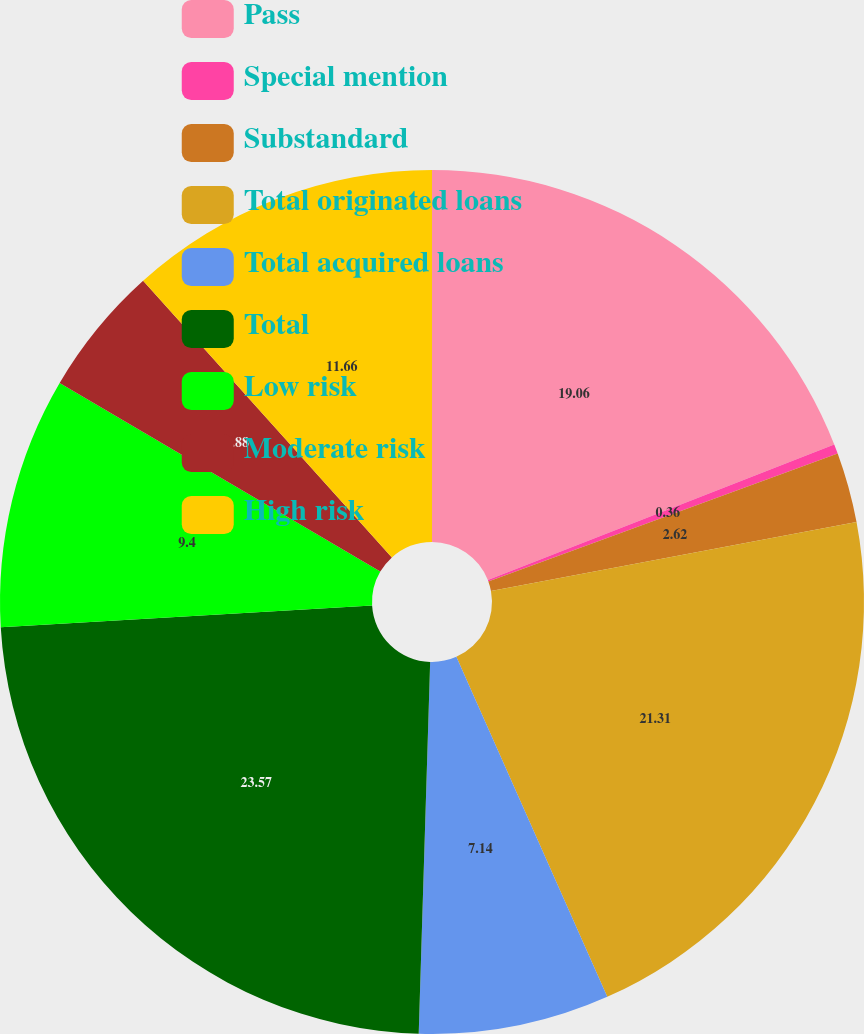Convert chart. <chart><loc_0><loc_0><loc_500><loc_500><pie_chart><fcel>Pass<fcel>Special mention<fcel>Substandard<fcel>Total originated loans<fcel>Total acquired loans<fcel>Total<fcel>Low risk<fcel>Moderate risk<fcel>High risk<nl><fcel>19.06%<fcel>0.36%<fcel>2.62%<fcel>21.32%<fcel>7.14%<fcel>23.58%<fcel>9.4%<fcel>4.88%<fcel>11.66%<nl></chart> 